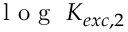Convert formula to latex. <formula><loc_0><loc_0><loc_500><loc_500>l o g K _ { e x c , 2 }</formula> 